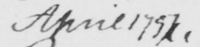What does this handwritten line say? April 1797 